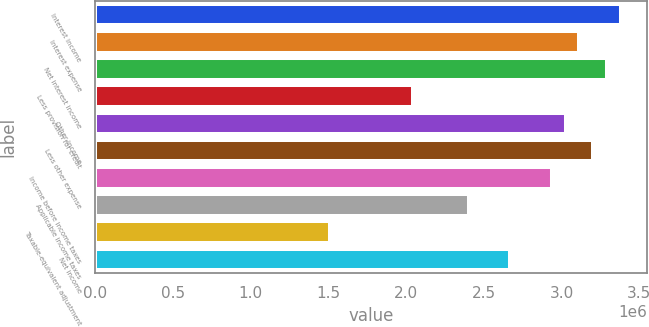Convert chart to OTSL. <chart><loc_0><loc_0><loc_500><loc_500><bar_chart><fcel>Interest income<fcel>Interest expense<fcel>Net interest income<fcel>Less provision for credit<fcel>Other income<fcel>Less other expense<fcel>Income before income taxes<fcel>Applicable income taxes<fcel>Taxable-equivalent adjustment<fcel>Net income<nl><fcel>3.38179e+06<fcel>3.11481e+06<fcel>3.29279e+06<fcel>2.04687e+06<fcel>3.02581e+06<fcel>3.2038e+06<fcel>2.93682e+06<fcel>2.40285e+06<fcel>1.51291e+06<fcel>2.66983e+06<nl></chart> 